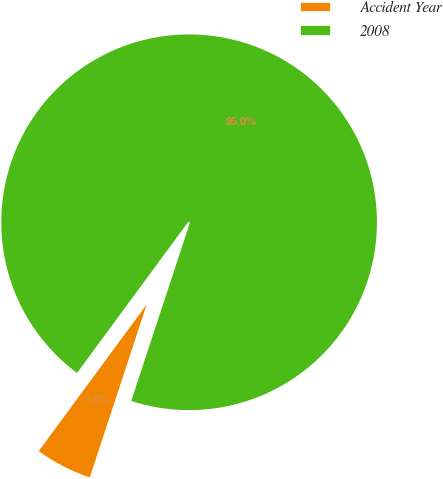Convert chart to OTSL. <chart><loc_0><loc_0><loc_500><loc_500><pie_chart><fcel>Accident Year<fcel>2008<nl><fcel>5.04%<fcel>94.96%<nl></chart> 